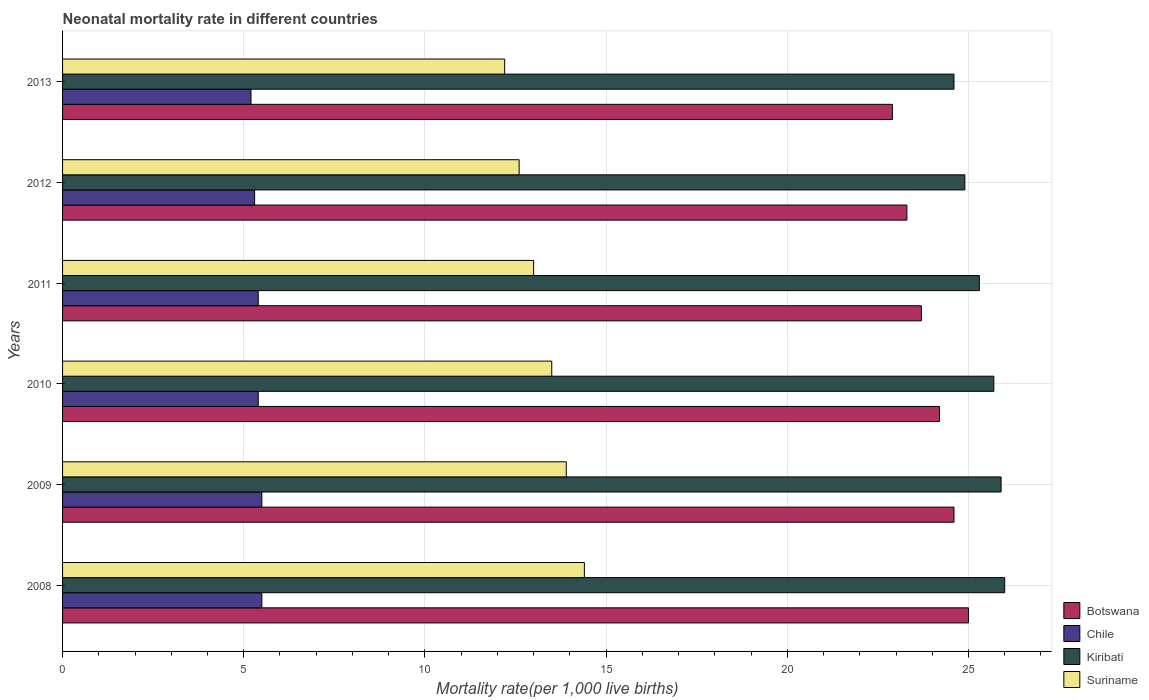In how many cases, is the number of bars for a given year not equal to the number of legend labels?
Offer a terse response. 0. What is the neonatal mortality rate in Botswana in 2012?
Make the answer very short. 23.3. Across all years, what is the maximum neonatal mortality rate in Kiribati?
Your answer should be very brief. 26. Across all years, what is the minimum neonatal mortality rate in Botswana?
Give a very brief answer. 22.9. In which year was the neonatal mortality rate in Suriname maximum?
Give a very brief answer. 2008. In which year was the neonatal mortality rate in Chile minimum?
Provide a short and direct response. 2013. What is the total neonatal mortality rate in Suriname in the graph?
Keep it short and to the point. 79.6. What is the difference between the neonatal mortality rate in Chile in 2009 and that in 2012?
Offer a very short reply. 0.2. What is the difference between the neonatal mortality rate in Chile in 2011 and the neonatal mortality rate in Kiribati in 2013?
Offer a terse response. -19.2. What is the average neonatal mortality rate in Botswana per year?
Your answer should be compact. 23.95. In how many years, is the neonatal mortality rate in Kiribati greater than 11 ?
Your answer should be very brief. 6. What is the ratio of the neonatal mortality rate in Suriname in 2008 to that in 2009?
Keep it short and to the point. 1.04. Is the neonatal mortality rate in Suriname in 2009 less than that in 2012?
Keep it short and to the point. No. Is the difference between the neonatal mortality rate in Kiribati in 2011 and 2013 greater than the difference between the neonatal mortality rate in Botswana in 2011 and 2013?
Keep it short and to the point. No. What is the difference between the highest and the lowest neonatal mortality rate in Kiribati?
Your answer should be very brief. 1.4. What does the 4th bar from the top in 2009 represents?
Your answer should be very brief. Botswana. What does the 3rd bar from the bottom in 2011 represents?
Offer a terse response. Kiribati. How many years are there in the graph?
Give a very brief answer. 6. Are the values on the major ticks of X-axis written in scientific E-notation?
Provide a succinct answer. No. Where does the legend appear in the graph?
Give a very brief answer. Bottom right. How are the legend labels stacked?
Your answer should be very brief. Vertical. What is the title of the graph?
Keep it short and to the point. Neonatal mortality rate in different countries. What is the label or title of the X-axis?
Give a very brief answer. Mortality rate(per 1,0 live births). What is the Mortality rate(per 1,000 live births) of Botswana in 2008?
Ensure brevity in your answer.  25. What is the Mortality rate(per 1,000 live births) in Kiribati in 2008?
Ensure brevity in your answer.  26. What is the Mortality rate(per 1,000 live births) in Botswana in 2009?
Provide a short and direct response. 24.6. What is the Mortality rate(per 1,000 live births) in Chile in 2009?
Offer a very short reply. 5.5. What is the Mortality rate(per 1,000 live births) in Kiribati in 2009?
Your response must be concise. 25.9. What is the Mortality rate(per 1,000 live births) in Botswana in 2010?
Your answer should be compact. 24.2. What is the Mortality rate(per 1,000 live births) of Kiribati in 2010?
Make the answer very short. 25.7. What is the Mortality rate(per 1,000 live births) of Suriname in 2010?
Keep it short and to the point. 13.5. What is the Mortality rate(per 1,000 live births) in Botswana in 2011?
Your answer should be very brief. 23.7. What is the Mortality rate(per 1,000 live births) of Chile in 2011?
Offer a terse response. 5.4. What is the Mortality rate(per 1,000 live births) of Kiribati in 2011?
Keep it short and to the point. 25.3. What is the Mortality rate(per 1,000 live births) of Suriname in 2011?
Your response must be concise. 13. What is the Mortality rate(per 1,000 live births) in Botswana in 2012?
Keep it short and to the point. 23.3. What is the Mortality rate(per 1,000 live births) of Kiribati in 2012?
Offer a terse response. 24.9. What is the Mortality rate(per 1,000 live births) in Suriname in 2012?
Provide a succinct answer. 12.6. What is the Mortality rate(per 1,000 live births) of Botswana in 2013?
Keep it short and to the point. 22.9. What is the Mortality rate(per 1,000 live births) in Kiribati in 2013?
Give a very brief answer. 24.6. Across all years, what is the maximum Mortality rate(per 1,000 live births) of Chile?
Provide a succinct answer. 5.5. Across all years, what is the maximum Mortality rate(per 1,000 live births) of Suriname?
Your response must be concise. 14.4. Across all years, what is the minimum Mortality rate(per 1,000 live births) in Botswana?
Your answer should be compact. 22.9. Across all years, what is the minimum Mortality rate(per 1,000 live births) of Chile?
Make the answer very short. 5.2. Across all years, what is the minimum Mortality rate(per 1,000 live births) in Kiribati?
Keep it short and to the point. 24.6. What is the total Mortality rate(per 1,000 live births) of Botswana in the graph?
Offer a very short reply. 143.7. What is the total Mortality rate(per 1,000 live births) in Chile in the graph?
Offer a very short reply. 32.3. What is the total Mortality rate(per 1,000 live births) of Kiribati in the graph?
Keep it short and to the point. 152.4. What is the total Mortality rate(per 1,000 live births) in Suriname in the graph?
Your answer should be very brief. 79.6. What is the difference between the Mortality rate(per 1,000 live births) of Botswana in 2008 and that in 2010?
Give a very brief answer. 0.8. What is the difference between the Mortality rate(per 1,000 live births) of Suriname in 2008 and that in 2010?
Your answer should be compact. 0.9. What is the difference between the Mortality rate(per 1,000 live births) in Botswana in 2008 and that in 2011?
Your answer should be very brief. 1.3. What is the difference between the Mortality rate(per 1,000 live births) in Chile in 2008 and that in 2011?
Keep it short and to the point. 0.1. What is the difference between the Mortality rate(per 1,000 live births) in Kiribati in 2008 and that in 2011?
Offer a very short reply. 0.7. What is the difference between the Mortality rate(per 1,000 live births) of Kiribati in 2008 and that in 2012?
Your answer should be very brief. 1.1. What is the difference between the Mortality rate(per 1,000 live births) in Suriname in 2008 and that in 2012?
Ensure brevity in your answer.  1.8. What is the difference between the Mortality rate(per 1,000 live births) of Kiribati in 2008 and that in 2013?
Provide a short and direct response. 1.4. What is the difference between the Mortality rate(per 1,000 live births) of Chile in 2009 and that in 2010?
Keep it short and to the point. 0.1. What is the difference between the Mortality rate(per 1,000 live births) of Kiribati in 2009 and that in 2010?
Your answer should be very brief. 0.2. What is the difference between the Mortality rate(per 1,000 live births) in Suriname in 2009 and that in 2010?
Keep it short and to the point. 0.4. What is the difference between the Mortality rate(per 1,000 live births) of Kiribati in 2009 and that in 2011?
Give a very brief answer. 0.6. What is the difference between the Mortality rate(per 1,000 live births) of Suriname in 2009 and that in 2011?
Give a very brief answer. 0.9. What is the difference between the Mortality rate(per 1,000 live births) of Kiribati in 2009 and that in 2012?
Keep it short and to the point. 1. What is the difference between the Mortality rate(per 1,000 live births) of Suriname in 2009 and that in 2012?
Provide a succinct answer. 1.3. What is the difference between the Mortality rate(per 1,000 live births) of Kiribati in 2009 and that in 2013?
Provide a short and direct response. 1.3. What is the difference between the Mortality rate(per 1,000 live births) of Botswana in 2010 and that in 2011?
Ensure brevity in your answer.  0.5. What is the difference between the Mortality rate(per 1,000 live births) of Chile in 2010 and that in 2011?
Keep it short and to the point. 0. What is the difference between the Mortality rate(per 1,000 live births) of Kiribati in 2010 and that in 2011?
Your answer should be compact. 0.4. What is the difference between the Mortality rate(per 1,000 live births) in Suriname in 2010 and that in 2011?
Offer a very short reply. 0.5. What is the difference between the Mortality rate(per 1,000 live births) of Botswana in 2010 and that in 2012?
Your response must be concise. 0.9. What is the difference between the Mortality rate(per 1,000 live births) in Chile in 2010 and that in 2012?
Make the answer very short. 0.1. What is the difference between the Mortality rate(per 1,000 live births) in Kiribati in 2010 and that in 2012?
Your answer should be very brief. 0.8. What is the difference between the Mortality rate(per 1,000 live births) of Suriname in 2010 and that in 2012?
Ensure brevity in your answer.  0.9. What is the difference between the Mortality rate(per 1,000 live births) of Botswana in 2010 and that in 2013?
Keep it short and to the point. 1.3. What is the difference between the Mortality rate(per 1,000 live births) of Kiribati in 2010 and that in 2013?
Make the answer very short. 1.1. What is the difference between the Mortality rate(per 1,000 live births) in Botswana in 2011 and that in 2012?
Your answer should be compact. 0.4. What is the difference between the Mortality rate(per 1,000 live births) in Kiribati in 2011 and that in 2012?
Offer a very short reply. 0.4. What is the difference between the Mortality rate(per 1,000 live births) in Suriname in 2011 and that in 2012?
Provide a short and direct response. 0.4. What is the difference between the Mortality rate(per 1,000 live births) in Botswana in 2011 and that in 2013?
Offer a terse response. 0.8. What is the difference between the Mortality rate(per 1,000 live births) in Chile in 2011 and that in 2013?
Make the answer very short. 0.2. What is the difference between the Mortality rate(per 1,000 live births) in Suriname in 2011 and that in 2013?
Make the answer very short. 0.8. What is the difference between the Mortality rate(per 1,000 live births) of Botswana in 2012 and that in 2013?
Provide a short and direct response. 0.4. What is the difference between the Mortality rate(per 1,000 live births) of Chile in 2012 and that in 2013?
Your answer should be very brief. 0.1. What is the difference between the Mortality rate(per 1,000 live births) of Kiribati in 2012 and that in 2013?
Your answer should be compact. 0.3. What is the difference between the Mortality rate(per 1,000 live births) in Suriname in 2012 and that in 2013?
Your answer should be very brief. 0.4. What is the difference between the Mortality rate(per 1,000 live births) of Botswana in 2008 and the Mortality rate(per 1,000 live births) of Kiribati in 2009?
Your answer should be compact. -0.9. What is the difference between the Mortality rate(per 1,000 live births) of Chile in 2008 and the Mortality rate(per 1,000 live births) of Kiribati in 2009?
Provide a short and direct response. -20.4. What is the difference between the Mortality rate(per 1,000 live births) in Chile in 2008 and the Mortality rate(per 1,000 live births) in Suriname in 2009?
Your answer should be very brief. -8.4. What is the difference between the Mortality rate(per 1,000 live births) of Kiribati in 2008 and the Mortality rate(per 1,000 live births) of Suriname in 2009?
Keep it short and to the point. 12.1. What is the difference between the Mortality rate(per 1,000 live births) of Botswana in 2008 and the Mortality rate(per 1,000 live births) of Chile in 2010?
Provide a short and direct response. 19.6. What is the difference between the Mortality rate(per 1,000 live births) of Chile in 2008 and the Mortality rate(per 1,000 live births) of Kiribati in 2010?
Your answer should be very brief. -20.2. What is the difference between the Mortality rate(per 1,000 live births) in Botswana in 2008 and the Mortality rate(per 1,000 live births) in Chile in 2011?
Keep it short and to the point. 19.6. What is the difference between the Mortality rate(per 1,000 live births) in Botswana in 2008 and the Mortality rate(per 1,000 live births) in Suriname in 2011?
Provide a succinct answer. 12. What is the difference between the Mortality rate(per 1,000 live births) in Chile in 2008 and the Mortality rate(per 1,000 live births) in Kiribati in 2011?
Your response must be concise. -19.8. What is the difference between the Mortality rate(per 1,000 live births) of Botswana in 2008 and the Mortality rate(per 1,000 live births) of Suriname in 2012?
Give a very brief answer. 12.4. What is the difference between the Mortality rate(per 1,000 live births) in Chile in 2008 and the Mortality rate(per 1,000 live births) in Kiribati in 2012?
Give a very brief answer. -19.4. What is the difference between the Mortality rate(per 1,000 live births) in Chile in 2008 and the Mortality rate(per 1,000 live births) in Suriname in 2012?
Offer a terse response. -7.1. What is the difference between the Mortality rate(per 1,000 live births) of Kiribati in 2008 and the Mortality rate(per 1,000 live births) of Suriname in 2012?
Provide a succinct answer. 13.4. What is the difference between the Mortality rate(per 1,000 live births) in Botswana in 2008 and the Mortality rate(per 1,000 live births) in Chile in 2013?
Offer a terse response. 19.8. What is the difference between the Mortality rate(per 1,000 live births) in Botswana in 2008 and the Mortality rate(per 1,000 live births) in Kiribati in 2013?
Make the answer very short. 0.4. What is the difference between the Mortality rate(per 1,000 live births) in Chile in 2008 and the Mortality rate(per 1,000 live births) in Kiribati in 2013?
Offer a terse response. -19.1. What is the difference between the Mortality rate(per 1,000 live births) of Kiribati in 2008 and the Mortality rate(per 1,000 live births) of Suriname in 2013?
Ensure brevity in your answer.  13.8. What is the difference between the Mortality rate(per 1,000 live births) of Botswana in 2009 and the Mortality rate(per 1,000 live births) of Suriname in 2010?
Offer a terse response. 11.1. What is the difference between the Mortality rate(per 1,000 live births) in Chile in 2009 and the Mortality rate(per 1,000 live births) in Kiribati in 2010?
Give a very brief answer. -20.2. What is the difference between the Mortality rate(per 1,000 live births) of Chile in 2009 and the Mortality rate(per 1,000 live births) of Suriname in 2010?
Your answer should be very brief. -8. What is the difference between the Mortality rate(per 1,000 live births) of Kiribati in 2009 and the Mortality rate(per 1,000 live births) of Suriname in 2010?
Provide a short and direct response. 12.4. What is the difference between the Mortality rate(per 1,000 live births) in Chile in 2009 and the Mortality rate(per 1,000 live births) in Kiribati in 2011?
Keep it short and to the point. -19.8. What is the difference between the Mortality rate(per 1,000 live births) of Kiribati in 2009 and the Mortality rate(per 1,000 live births) of Suriname in 2011?
Your answer should be compact. 12.9. What is the difference between the Mortality rate(per 1,000 live births) in Botswana in 2009 and the Mortality rate(per 1,000 live births) in Chile in 2012?
Provide a succinct answer. 19.3. What is the difference between the Mortality rate(per 1,000 live births) in Chile in 2009 and the Mortality rate(per 1,000 live births) in Kiribati in 2012?
Your answer should be very brief. -19.4. What is the difference between the Mortality rate(per 1,000 live births) of Chile in 2009 and the Mortality rate(per 1,000 live births) of Suriname in 2012?
Your answer should be very brief. -7.1. What is the difference between the Mortality rate(per 1,000 live births) in Kiribati in 2009 and the Mortality rate(per 1,000 live births) in Suriname in 2012?
Offer a terse response. 13.3. What is the difference between the Mortality rate(per 1,000 live births) in Chile in 2009 and the Mortality rate(per 1,000 live births) in Kiribati in 2013?
Offer a very short reply. -19.1. What is the difference between the Mortality rate(per 1,000 live births) in Kiribati in 2009 and the Mortality rate(per 1,000 live births) in Suriname in 2013?
Your answer should be compact. 13.7. What is the difference between the Mortality rate(per 1,000 live births) of Botswana in 2010 and the Mortality rate(per 1,000 live births) of Kiribati in 2011?
Keep it short and to the point. -1.1. What is the difference between the Mortality rate(per 1,000 live births) in Botswana in 2010 and the Mortality rate(per 1,000 live births) in Suriname in 2011?
Provide a short and direct response. 11.2. What is the difference between the Mortality rate(per 1,000 live births) in Chile in 2010 and the Mortality rate(per 1,000 live births) in Kiribati in 2011?
Your answer should be compact. -19.9. What is the difference between the Mortality rate(per 1,000 live births) of Chile in 2010 and the Mortality rate(per 1,000 live births) of Suriname in 2011?
Your answer should be very brief. -7.6. What is the difference between the Mortality rate(per 1,000 live births) of Chile in 2010 and the Mortality rate(per 1,000 live births) of Kiribati in 2012?
Ensure brevity in your answer.  -19.5. What is the difference between the Mortality rate(per 1,000 live births) of Botswana in 2010 and the Mortality rate(per 1,000 live births) of Chile in 2013?
Your answer should be compact. 19. What is the difference between the Mortality rate(per 1,000 live births) in Botswana in 2010 and the Mortality rate(per 1,000 live births) in Suriname in 2013?
Your answer should be compact. 12. What is the difference between the Mortality rate(per 1,000 live births) of Chile in 2010 and the Mortality rate(per 1,000 live births) of Kiribati in 2013?
Your response must be concise. -19.2. What is the difference between the Mortality rate(per 1,000 live births) in Kiribati in 2010 and the Mortality rate(per 1,000 live births) in Suriname in 2013?
Your answer should be compact. 13.5. What is the difference between the Mortality rate(per 1,000 live births) in Botswana in 2011 and the Mortality rate(per 1,000 live births) in Chile in 2012?
Provide a short and direct response. 18.4. What is the difference between the Mortality rate(per 1,000 live births) in Chile in 2011 and the Mortality rate(per 1,000 live births) in Kiribati in 2012?
Offer a terse response. -19.5. What is the difference between the Mortality rate(per 1,000 live births) of Chile in 2011 and the Mortality rate(per 1,000 live births) of Suriname in 2012?
Keep it short and to the point. -7.2. What is the difference between the Mortality rate(per 1,000 live births) of Kiribati in 2011 and the Mortality rate(per 1,000 live births) of Suriname in 2012?
Offer a very short reply. 12.7. What is the difference between the Mortality rate(per 1,000 live births) of Botswana in 2011 and the Mortality rate(per 1,000 live births) of Chile in 2013?
Keep it short and to the point. 18.5. What is the difference between the Mortality rate(per 1,000 live births) of Chile in 2011 and the Mortality rate(per 1,000 live births) of Kiribati in 2013?
Give a very brief answer. -19.2. What is the difference between the Mortality rate(per 1,000 live births) of Chile in 2011 and the Mortality rate(per 1,000 live births) of Suriname in 2013?
Your answer should be very brief. -6.8. What is the difference between the Mortality rate(per 1,000 live births) of Botswana in 2012 and the Mortality rate(per 1,000 live births) of Suriname in 2013?
Your answer should be very brief. 11.1. What is the difference between the Mortality rate(per 1,000 live births) in Chile in 2012 and the Mortality rate(per 1,000 live births) in Kiribati in 2013?
Offer a very short reply. -19.3. What is the difference between the Mortality rate(per 1,000 live births) of Chile in 2012 and the Mortality rate(per 1,000 live births) of Suriname in 2013?
Your response must be concise. -6.9. What is the difference between the Mortality rate(per 1,000 live births) of Kiribati in 2012 and the Mortality rate(per 1,000 live births) of Suriname in 2013?
Ensure brevity in your answer.  12.7. What is the average Mortality rate(per 1,000 live births) of Botswana per year?
Your answer should be very brief. 23.95. What is the average Mortality rate(per 1,000 live births) of Chile per year?
Your response must be concise. 5.38. What is the average Mortality rate(per 1,000 live births) in Kiribati per year?
Provide a short and direct response. 25.4. What is the average Mortality rate(per 1,000 live births) in Suriname per year?
Keep it short and to the point. 13.27. In the year 2008, what is the difference between the Mortality rate(per 1,000 live births) in Botswana and Mortality rate(per 1,000 live births) in Chile?
Your response must be concise. 19.5. In the year 2008, what is the difference between the Mortality rate(per 1,000 live births) of Chile and Mortality rate(per 1,000 live births) of Kiribati?
Your response must be concise. -20.5. In the year 2008, what is the difference between the Mortality rate(per 1,000 live births) of Kiribati and Mortality rate(per 1,000 live births) of Suriname?
Your answer should be compact. 11.6. In the year 2009, what is the difference between the Mortality rate(per 1,000 live births) of Botswana and Mortality rate(per 1,000 live births) of Chile?
Your answer should be compact. 19.1. In the year 2009, what is the difference between the Mortality rate(per 1,000 live births) of Chile and Mortality rate(per 1,000 live births) of Kiribati?
Provide a short and direct response. -20.4. In the year 2009, what is the difference between the Mortality rate(per 1,000 live births) of Chile and Mortality rate(per 1,000 live births) of Suriname?
Make the answer very short. -8.4. In the year 2009, what is the difference between the Mortality rate(per 1,000 live births) of Kiribati and Mortality rate(per 1,000 live births) of Suriname?
Ensure brevity in your answer.  12. In the year 2010, what is the difference between the Mortality rate(per 1,000 live births) of Botswana and Mortality rate(per 1,000 live births) of Chile?
Ensure brevity in your answer.  18.8. In the year 2010, what is the difference between the Mortality rate(per 1,000 live births) in Botswana and Mortality rate(per 1,000 live births) in Kiribati?
Give a very brief answer. -1.5. In the year 2010, what is the difference between the Mortality rate(per 1,000 live births) of Botswana and Mortality rate(per 1,000 live births) of Suriname?
Give a very brief answer. 10.7. In the year 2010, what is the difference between the Mortality rate(per 1,000 live births) of Chile and Mortality rate(per 1,000 live births) of Kiribati?
Your answer should be compact. -20.3. In the year 2010, what is the difference between the Mortality rate(per 1,000 live births) of Kiribati and Mortality rate(per 1,000 live births) of Suriname?
Make the answer very short. 12.2. In the year 2011, what is the difference between the Mortality rate(per 1,000 live births) of Botswana and Mortality rate(per 1,000 live births) of Kiribati?
Your answer should be compact. -1.6. In the year 2011, what is the difference between the Mortality rate(per 1,000 live births) of Chile and Mortality rate(per 1,000 live births) of Kiribati?
Keep it short and to the point. -19.9. In the year 2011, what is the difference between the Mortality rate(per 1,000 live births) of Kiribati and Mortality rate(per 1,000 live births) of Suriname?
Your answer should be very brief. 12.3. In the year 2012, what is the difference between the Mortality rate(per 1,000 live births) in Botswana and Mortality rate(per 1,000 live births) in Suriname?
Your answer should be very brief. 10.7. In the year 2012, what is the difference between the Mortality rate(per 1,000 live births) of Chile and Mortality rate(per 1,000 live births) of Kiribati?
Offer a very short reply. -19.6. In the year 2012, what is the difference between the Mortality rate(per 1,000 live births) of Chile and Mortality rate(per 1,000 live births) of Suriname?
Your response must be concise. -7.3. In the year 2013, what is the difference between the Mortality rate(per 1,000 live births) in Botswana and Mortality rate(per 1,000 live births) in Kiribati?
Give a very brief answer. -1.7. In the year 2013, what is the difference between the Mortality rate(per 1,000 live births) in Chile and Mortality rate(per 1,000 live births) in Kiribati?
Your answer should be compact. -19.4. In the year 2013, what is the difference between the Mortality rate(per 1,000 live births) of Chile and Mortality rate(per 1,000 live births) of Suriname?
Make the answer very short. -7. What is the ratio of the Mortality rate(per 1,000 live births) in Botswana in 2008 to that in 2009?
Keep it short and to the point. 1.02. What is the ratio of the Mortality rate(per 1,000 live births) of Chile in 2008 to that in 2009?
Make the answer very short. 1. What is the ratio of the Mortality rate(per 1,000 live births) of Suriname in 2008 to that in 2009?
Give a very brief answer. 1.04. What is the ratio of the Mortality rate(per 1,000 live births) in Botswana in 2008 to that in 2010?
Your answer should be very brief. 1.03. What is the ratio of the Mortality rate(per 1,000 live births) in Chile in 2008 to that in 2010?
Your answer should be very brief. 1.02. What is the ratio of the Mortality rate(per 1,000 live births) in Kiribati in 2008 to that in 2010?
Your response must be concise. 1.01. What is the ratio of the Mortality rate(per 1,000 live births) in Suriname in 2008 to that in 2010?
Your response must be concise. 1.07. What is the ratio of the Mortality rate(per 1,000 live births) in Botswana in 2008 to that in 2011?
Your answer should be compact. 1.05. What is the ratio of the Mortality rate(per 1,000 live births) in Chile in 2008 to that in 2011?
Your answer should be compact. 1.02. What is the ratio of the Mortality rate(per 1,000 live births) in Kiribati in 2008 to that in 2011?
Provide a succinct answer. 1.03. What is the ratio of the Mortality rate(per 1,000 live births) of Suriname in 2008 to that in 2011?
Offer a terse response. 1.11. What is the ratio of the Mortality rate(per 1,000 live births) of Botswana in 2008 to that in 2012?
Make the answer very short. 1.07. What is the ratio of the Mortality rate(per 1,000 live births) in Chile in 2008 to that in 2012?
Provide a short and direct response. 1.04. What is the ratio of the Mortality rate(per 1,000 live births) of Kiribati in 2008 to that in 2012?
Your answer should be very brief. 1.04. What is the ratio of the Mortality rate(per 1,000 live births) in Suriname in 2008 to that in 2012?
Your response must be concise. 1.14. What is the ratio of the Mortality rate(per 1,000 live births) in Botswana in 2008 to that in 2013?
Make the answer very short. 1.09. What is the ratio of the Mortality rate(per 1,000 live births) of Chile in 2008 to that in 2013?
Give a very brief answer. 1.06. What is the ratio of the Mortality rate(per 1,000 live births) in Kiribati in 2008 to that in 2013?
Your response must be concise. 1.06. What is the ratio of the Mortality rate(per 1,000 live births) in Suriname in 2008 to that in 2013?
Offer a very short reply. 1.18. What is the ratio of the Mortality rate(per 1,000 live births) in Botswana in 2009 to that in 2010?
Give a very brief answer. 1.02. What is the ratio of the Mortality rate(per 1,000 live births) of Chile in 2009 to that in 2010?
Your response must be concise. 1.02. What is the ratio of the Mortality rate(per 1,000 live births) in Suriname in 2009 to that in 2010?
Give a very brief answer. 1.03. What is the ratio of the Mortality rate(per 1,000 live births) in Botswana in 2009 to that in 2011?
Offer a terse response. 1.04. What is the ratio of the Mortality rate(per 1,000 live births) of Chile in 2009 to that in 2011?
Provide a short and direct response. 1.02. What is the ratio of the Mortality rate(per 1,000 live births) of Kiribati in 2009 to that in 2011?
Offer a very short reply. 1.02. What is the ratio of the Mortality rate(per 1,000 live births) in Suriname in 2009 to that in 2011?
Offer a terse response. 1.07. What is the ratio of the Mortality rate(per 1,000 live births) of Botswana in 2009 to that in 2012?
Keep it short and to the point. 1.06. What is the ratio of the Mortality rate(per 1,000 live births) in Chile in 2009 to that in 2012?
Make the answer very short. 1.04. What is the ratio of the Mortality rate(per 1,000 live births) of Kiribati in 2009 to that in 2012?
Offer a terse response. 1.04. What is the ratio of the Mortality rate(per 1,000 live births) of Suriname in 2009 to that in 2012?
Your answer should be very brief. 1.1. What is the ratio of the Mortality rate(per 1,000 live births) of Botswana in 2009 to that in 2013?
Make the answer very short. 1.07. What is the ratio of the Mortality rate(per 1,000 live births) in Chile in 2009 to that in 2013?
Your answer should be compact. 1.06. What is the ratio of the Mortality rate(per 1,000 live births) of Kiribati in 2009 to that in 2013?
Ensure brevity in your answer.  1.05. What is the ratio of the Mortality rate(per 1,000 live births) in Suriname in 2009 to that in 2013?
Offer a terse response. 1.14. What is the ratio of the Mortality rate(per 1,000 live births) in Botswana in 2010 to that in 2011?
Provide a short and direct response. 1.02. What is the ratio of the Mortality rate(per 1,000 live births) in Kiribati in 2010 to that in 2011?
Give a very brief answer. 1.02. What is the ratio of the Mortality rate(per 1,000 live births) of Botswana in 2010 to that in 2012?
Your answer should be compact. 1.04. What is the ratio of the Mortality rate(per 1,000 live births) in Chile in 2010 to that in 2012?
Your response must be concise. 1.02. What is the ratio of the Mortality rate(per 1,000 live births) in Kiribati in 2010 to that in 2012?
Your answer should be very brief. 1.03. What is the ratio of the Mortality rate(per 1,000 live births) of Suriname in 2010 to that in 2012?
Provide a succinct answer. 1.07. What is the ratio of the Mortality rate(per 1,000 live births) in Botswana in 2010 to that in 2013?
Make the answer very short. 1.06. What is the ratio of the Mortality rate(per 1,000 live births) in Kiribati in 2010 to that in 2013?
Give a very brief answer. 1.04. What is the ratio of the Mortality rate(per 1,000 live births) in Suriname in 2010 to that in 2013?
Your response must be concise. 1.11. What is the ratio of the Mortality rate(per 1,000 live births) of Botswana in 2011 to that in 2012?
Make the answer very short. 1.02. What is the ratio of the Mortality rate(per 1,000 live births) in Chile in 2011 to that in 2012?
Offer a terse response. 1.02. What is the ratio of the Mortality rate(per 1,000 live births) of Kiribati in 2011 to that in 2012?
Offer a terse response. 1.02. What is the ratio of the Mortality rate(per 1,000 live births) of Suriname in 2011 to that in 2012?
Offer a terse response. 1.03. What is the ratio of the Mortality rate(per 1,000 live births) in Botswana in 2011 to that in 2013?
Provide a short and direct response. 1.03. What is the ratio of the Mortality rate(per 1,000 live births) of Chile in 2011 to that in 2013?
Provide a succinct answer. 1.04. What is the ratio of the Mortality rate(per 1,000 live births) of Kiribati in 2011 to that in 2013?
Give a very brief answer. 1.03. What is the ratio of the Mortality rate(per 1,000 live births) of Suriname in 2011 to that in 2013?
Keep it short and to the point. 1.07. What is the ratio of the Mortality rate(per 1,000 live births) of Botswana in 2012 to that in 2013?
Offer a very short reply. 1.02. What is the ratio of the Mortality rate(per 1,000 live births) in Chile in 2012 to that in 2013?
Provide a succinct answer. 1.02. What is the ratio of the Mortality rate(per 1,000 live births) in Kiribati in 2012 to that in 2013?
Your answer should be very brief. 1.01. What is the ratio of the Mortality rate(per 1,000 live births) of Suriname in 2012 to that in 2013?
Offer a very short reply. 1.03. What is the difference between the highest and the second highest Mortality rate(per 1,000 live births) in Botswana?
Ensure brevity in your answer.  0.4. What is the difference between the highest and the second highest Mortality rate(per 1,000 live births) in Kiribati?
Your response must be concise. 0.1. What is the difference between the highest and the second highest Mortality rate(per 1,000 live births) in Suriname?
Offer a terse response. 0.5. What is the difference between the highest and the lowest Mortality rate(per 1,000 live births) of Botswana?
Keep it short and to the point. 2.1. What is the difference between the highest and the lowest Mortality rate(per 1,000 live births) of Chile?
Your answer should be very brief. 0.3. What is the difference between the highest and the lowest Mortality rate(per 1,000 live births) in Kiribati?
Offer a very short reply. 1.4. 